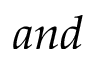<formula> <loc_0><loc_0><loc_500><loc_500>a n d</formula> 